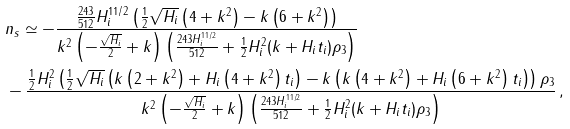<formula> <loc_0><loc_0><loc_500><loc_500>& n _ { s } \simeq - \frac { \frac { 2 4 3 } { 5 1 2 } H _ { i } ^ { 1 1 / 2 } \left ( \frac { 1 } { 2 } \sqrt { H _ { i } } \left ( 4 + k ^ { 2 } \right ) - k \left ( 6 + k ^ { 2 } \right ) \right ) } { k ^ { 2 } \left ( - \frac { \sqrt { H _ { i } } } { 2 } + k \right ) \left ( \frac { 2 4 3 H _ { i } ^ { 1 1 / 2 } } { 5 1 2 } + \frac { 1 } { 2 } H _ { i } ^ { 2 } ( k + H _ { i } t _ { i } ) \rho _ { 3 } \right ) } \\ & - \frac { \frac { 1 } { 2 } H _ { i } ^ { 2 } \left ( \frac { 1 } { 2 } \sqrt { H _ { i } } \left ( k \left ( 2 + k ^ { 2 } \right ) + H _ { i } \left ( 4 + k ^ { 2 } \right ) t _ { i } \right ) - k \left ( k \left ( 4 + k ^ { 2 } \right ) + H _ { i } \left ( 6 + k ^ { 2 } \right ) t _ { i } \right ) \right ) \rho _ { 3 } } { k ^ { 2 } \left ( - \frac { \sqrt { H _ { i } } } { 2 } + k \right ) \left ( \frac { 2 4 3 H _ { i } ^ { 1 1 / 2 } } { 5 1 2 } + \frac { 1 } { 2 } H _ { i } ^ { 2 } ( k + H _ { i } t _ { i } ) \rho _ { 3 } \right ) } \, ,</formula> 